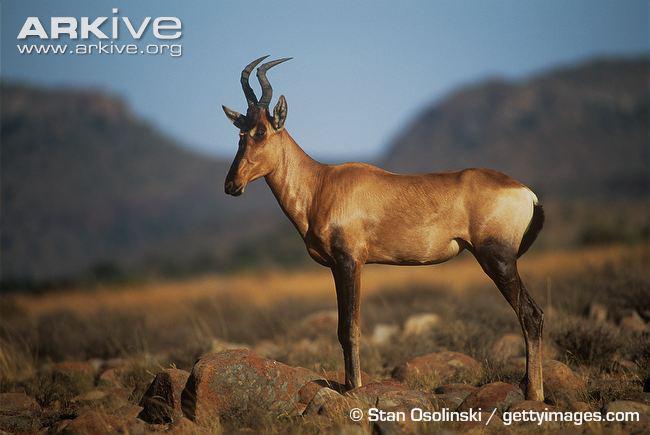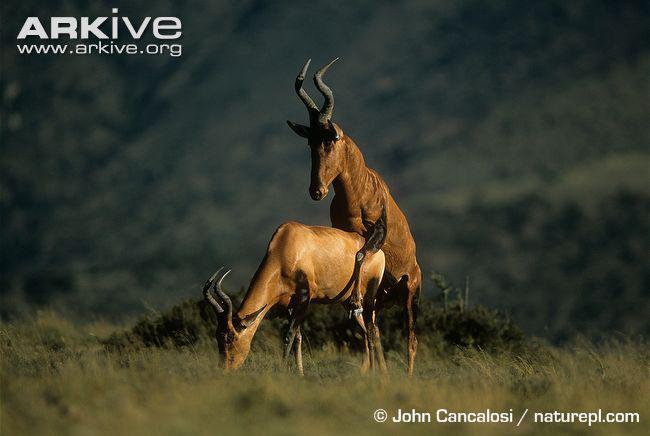The first image is the image on the left, the second image is the image on the right. Considering the images on both sides, is "One image contains two upright horned animals engaged in physical contact, and the other image contains one horned animal standing in profile." valid? Answer yes or no. Yes. The first image is the image on the left, the second image is the image on the right. Evaluate the accuracy of this statement regarding the images: "There are exactly three goats.". Is it true? Answer yes or no. Yes. The first image is the image on the left, the second image is the image on the right. Given the left and right images, does the statement "The left and right image contains a total of three antelope." hold true? Answer yes or no. Yes. The first image is the image on the left, the second image is the image on the right. For the images shown, is this caption "The right image shows one horned animal standing behind another horned animal, with its front legs wrapped around the animal's back." true? Answer yes or no. Yes. 